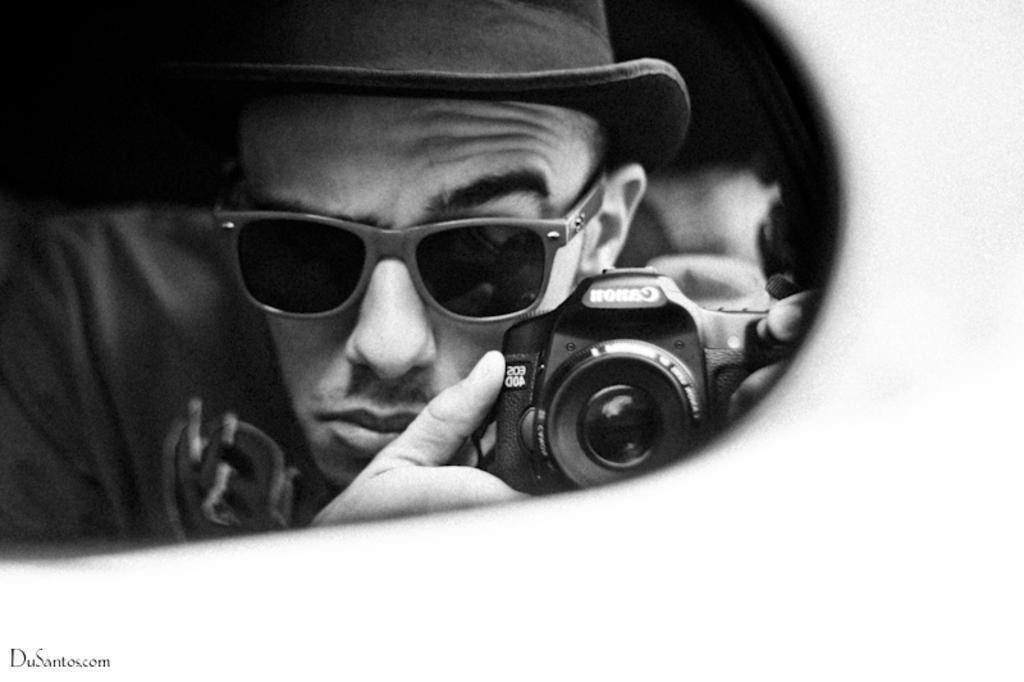Describe this image in one or two sentences. In this image I can see a man holding a camera where canon is written on it. I can also see he is wearing a shade and a cap. 